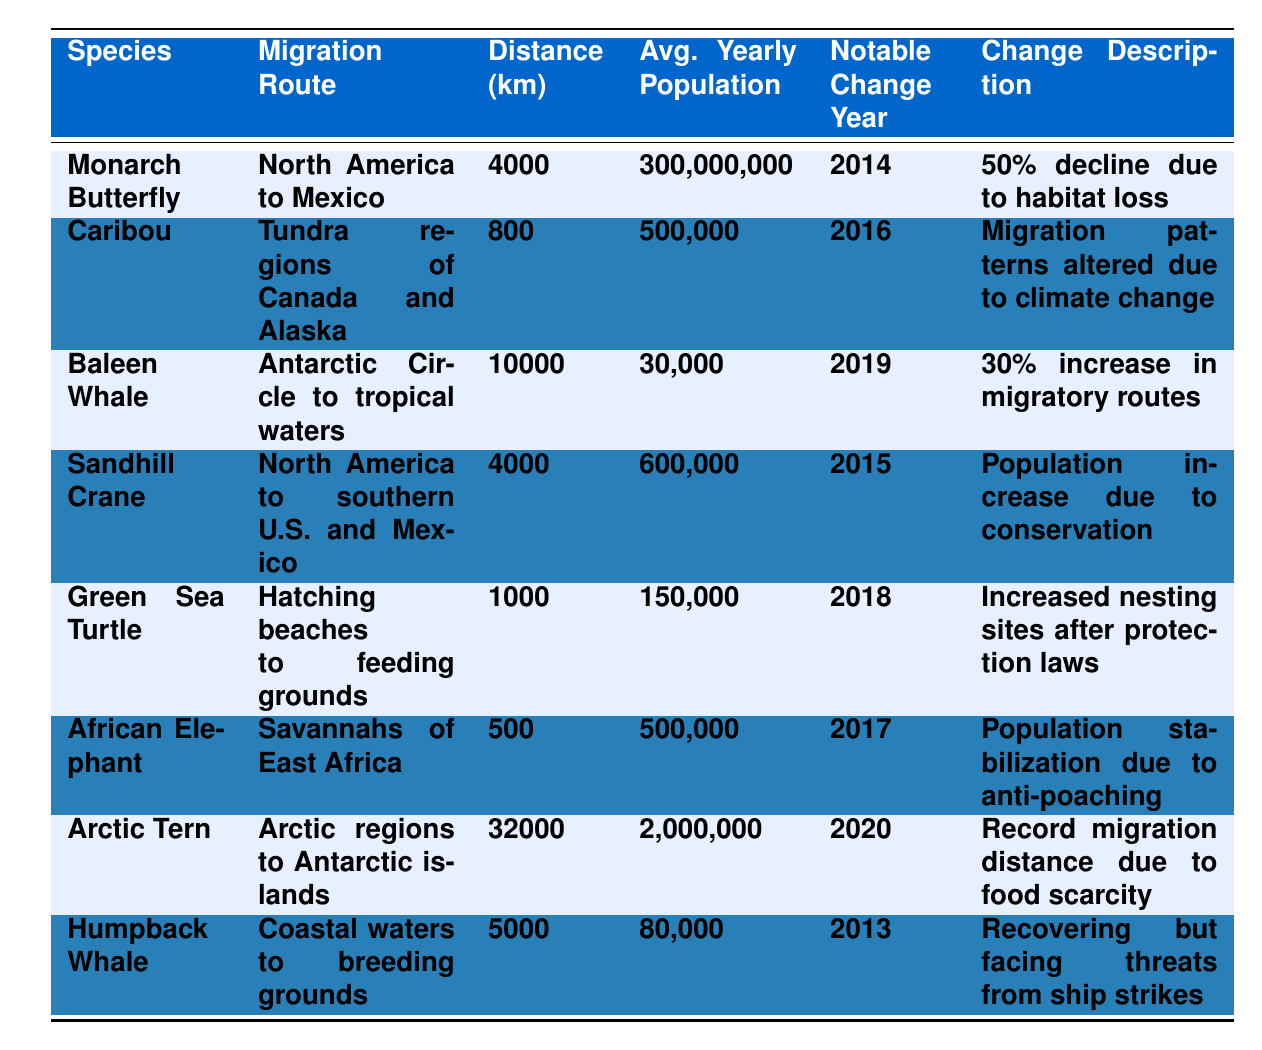What is the migration distance of the Monarch Butterfly? The table lists the migration distance for the Monarch Butterfly as 4,000 kilometers.
Answer: 4,000 km Which species has the largest average yearly population? By comparing the average yearly populations of all species in the table, the Monarch Butterfly has the largest population at 300,000,000.
Answer: 300,000,000 How many kilometers does the Arctic Tern migrate? The Arctic Tern has a migration distance of 32,000 kilometers as indicated in the table.
Answer: 32,000 km Which species experienced a notable change in population due to conservation efforts? The Sandhill Crane experienced an increase in population due to conservation efforts as stated in the Change Description column.
Answer: Sandhill Crane What is the total migration distance of the Baleen Whale and Humpback Whale combined? The Baleen Whale migrates 10,000 kilometers, and the Humpback Whale migrates 5,000 kilometers. Summing these gives us 10,000 + 5,000 = 15,000 kilometers combined.
Answer: 15,000 km Did the African Elephant's population see any stabilization efforts? Yes, the table notes that the African Elephant's population stabilized due to anti-poaching efforts.
Answer: Yes Which species migrated the shortest distance? The Green Sea Turtle migrates the shortest distance of 1,000 kilometers, as seen in the table.
Answer: 1,000 km Is it true that the Caribou's migration patterns were affected by climate change? Yes, the table confirms that the Caribou's migration patterns were altered due to climate change in the notable change year of 2016.
Answer: Yes What was the average yearly population of the Arctic Tern and how does it compare to the average yearly population of the Green Sea Turtle? The Arctic Tern has an average yearly population of 2,000,000 while the Green Sea Turtle has 150,000. The Arctic Tern's population is significantly higher, 2,000,000 vs 150,000.
Answer: 2,000,000 (Arctic Tern is higher) Which species showed a recorded increase in migratory routes? The Baleen Whale showed a reported increase in migratory routes by 30% in 2019.
Answer: Baleen Whale What percentage decline did the Monarch Butterfly experience in 2014? The Monarch Butterfly experienced a 50% decline in population in 2014 due to habitat loss according to the Change Description.
Answer: 50% 